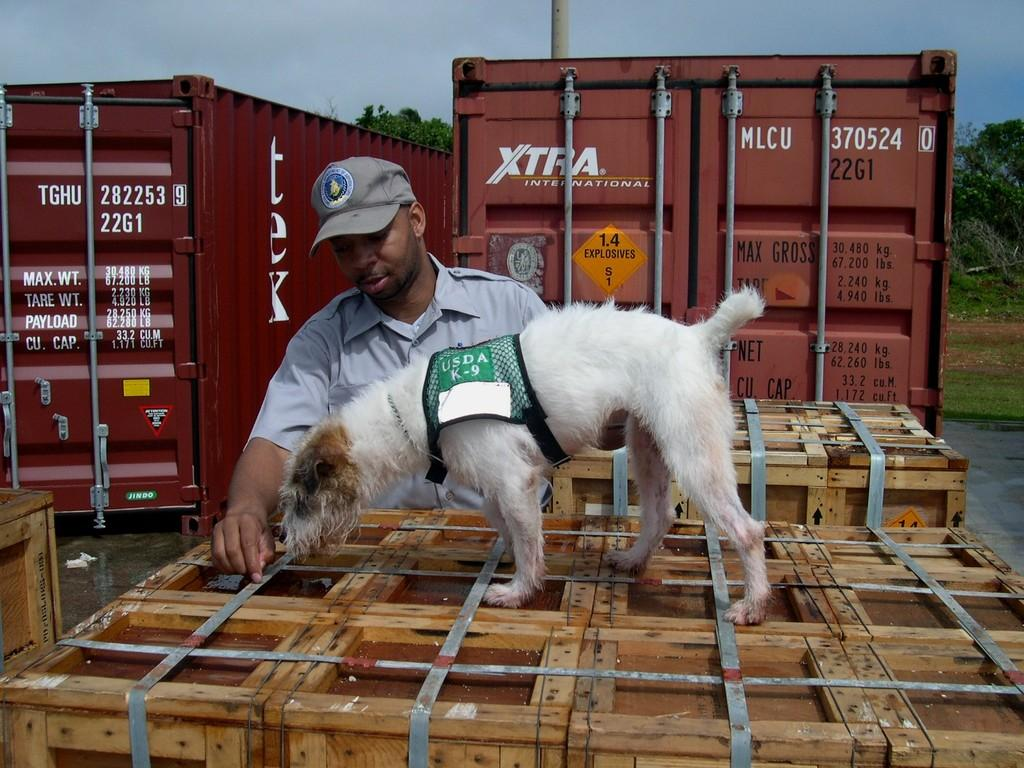What is present in the image along with the person? There is a dog in the image along with the person. What can be found on the ground in the image? There are wooden objects on the ground. What can be seen in the background of the image? In the background of the image, there are containers, trees, a pole, and the sky. What type of song is the person singing in the image? There is no indication in the image that the person is singing a song, so it cannot be determined from the picture. 